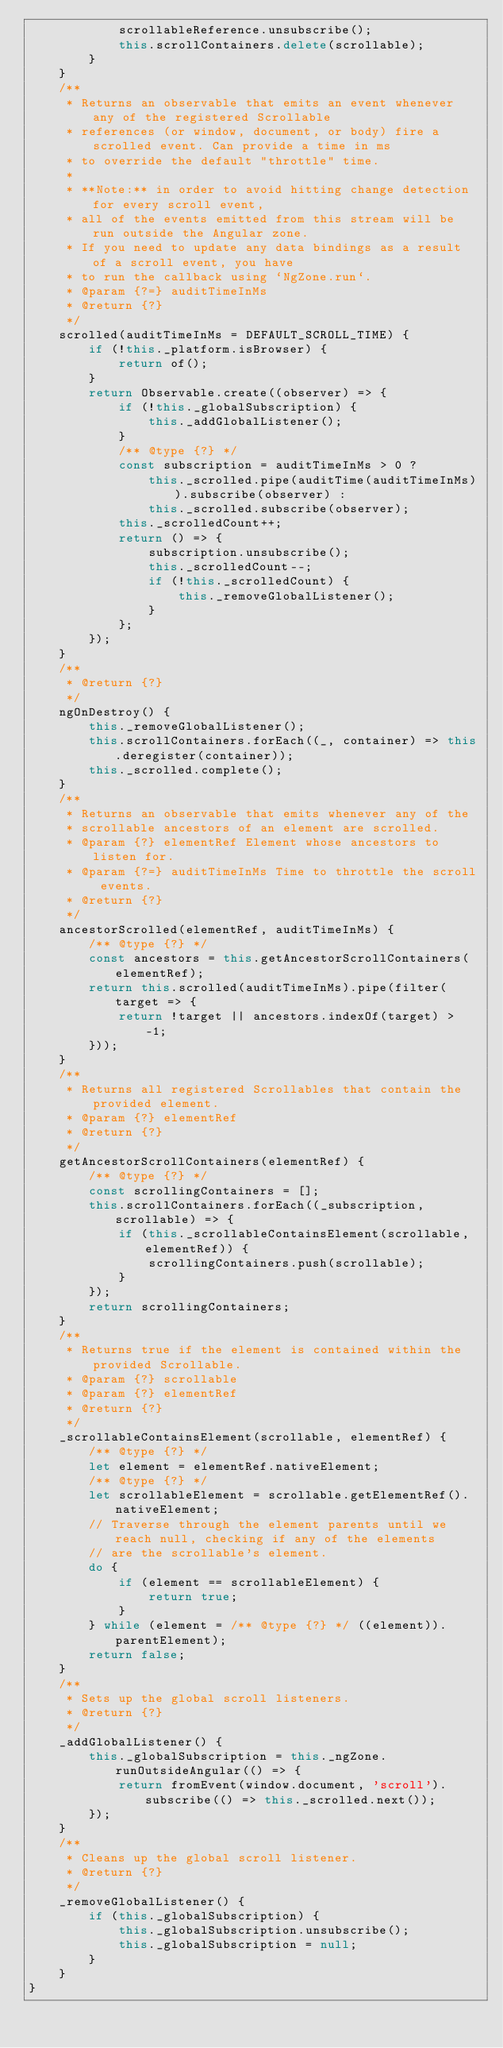<code> <loc_0><loc_0><loc_500><loc_500><_JavaScript_>            scrollableReference.unsubscribe();
            this.scrollContainers.delete(scrollable);
        }
    }
    /**
     * Returns an observable that emits an event whenever any of the registered Scrollable
     * references (or window, document, or body) fire a scrolled event. Can provide a time in ms
     * to override the default "throttle" time.
     *
     * **Note:** in order to avoid hitting change detection for every scroll event,
     * all of the events emitted from this stream will be run outside the Angular zone.
     * If you need to update any data bindings as a result of a scroll event, you have
     * to run the callback using `NgZone.run`.
     * @param {?=} auditTimeInMs
     * @return {?}
     */
    scrolled(auditTimeInMs = DEFAULT_SCROLL_TIME) {
        if (!this._platform.isBrowser) {
            return of();
        }
        return Observable.create((observer) => {
            if (!this._globalSubscription) {
                this._addGlobalListener();
            }
            /** @type {?} */
            const subscription = auditTimeInMs > 0 ?
                this._scrolled.pipe(auditTime(auditTimeInMs)).subscribe(observer) :
                this._scrolled.subscribe(observer);
            this._scrolledCount++;
            return () => {
                subscription.unsubscribe();
                this._scrolledCount--;
                if (!this._scrolledCount) {
                    this._removeGlobalListener();
                }
            };
        });
    }
    /**
     * @return {?}
     */
    ngOnDestroy() {
        this._removeGlobalListener();
        this.scrollContainers.forEach((_, container) => this.deregister(container));
        this._scrolled.complete();
    }
    /**
     * Returns an observable that emits whenever any of the
     * scrollable ancestors of an element are scrolled.
     * @param {?} elementRef Element whose ancestors to listen for.
     * @param {?=} auditTimeInMs Time to throttle the scroll events.
     * @return {?}
     */
    ancestorScrolled(elementRef, auditTimeInMs) {
        /** @type {?} */
        const ancestors = this.getAncestorScrollContainers(elementRef);
        return this.scrolled(auditTimeInMs).pipe(filter(target => {
            return !target || ancestors.indexOf(target) > -1;
        }));
    }
    /**
     * Returns all registered Scrollables that contain the provided element.
     * @param {?} elementRef
     * @return {?}
     */
    getAncestorScrollContainers(elementRef) {
        /** @type {?} */
        const scrollingContainers = [];
        this.scrollContainers.forEach((_subscription, scrollable) => {
            if (this._scrollableContainsElement(scrollable, elementRef)) {
                scrollingContainers.push(scrollable);
            }
        });
        return scrollingContainers;
    }
    /**
     * Returns true if the element is contained within the provided Scrollable.
     * @param {?} scrollable
     * @param {?} elementRef
     * @return {?}
     */
    _scrollableContainsElement(scrollable, elementRef) {
        /** @type {?} */
        let element = elementRef.nativeElement;
        /** @type {?} */
        let scrollableElement = scrollable.getElementRef().nativeElement;
        // Traverse through the element parents until we reach null, checking if any of the elements
        // are the scrollable's element.
        do {
            if (element == scrollableElement) {
                return true;
            }
        } while (element = /** @type {?} */ ((element)).parentElement);
        return false;
    }
    /**
     * Sets up the global scroll listeners.
     * @return {?}
     */
    _addGlobalListener() {
        this._globalSubscription = this._ngZone.runOutsideAngular(() => {
            return fromEvent(window.document, 'scroll').subscribe(() => this._scrolled.next());
        });
    }
    /**
     * Cleans up the global scroll listener.
     * @return {?}
     */
    _removeGlobalListener() {
        if (this._globalSubscription) {
            this._globalSubscription.unsubscribe();
            this._globalSubscription = null;
        }
    }
}</code> 